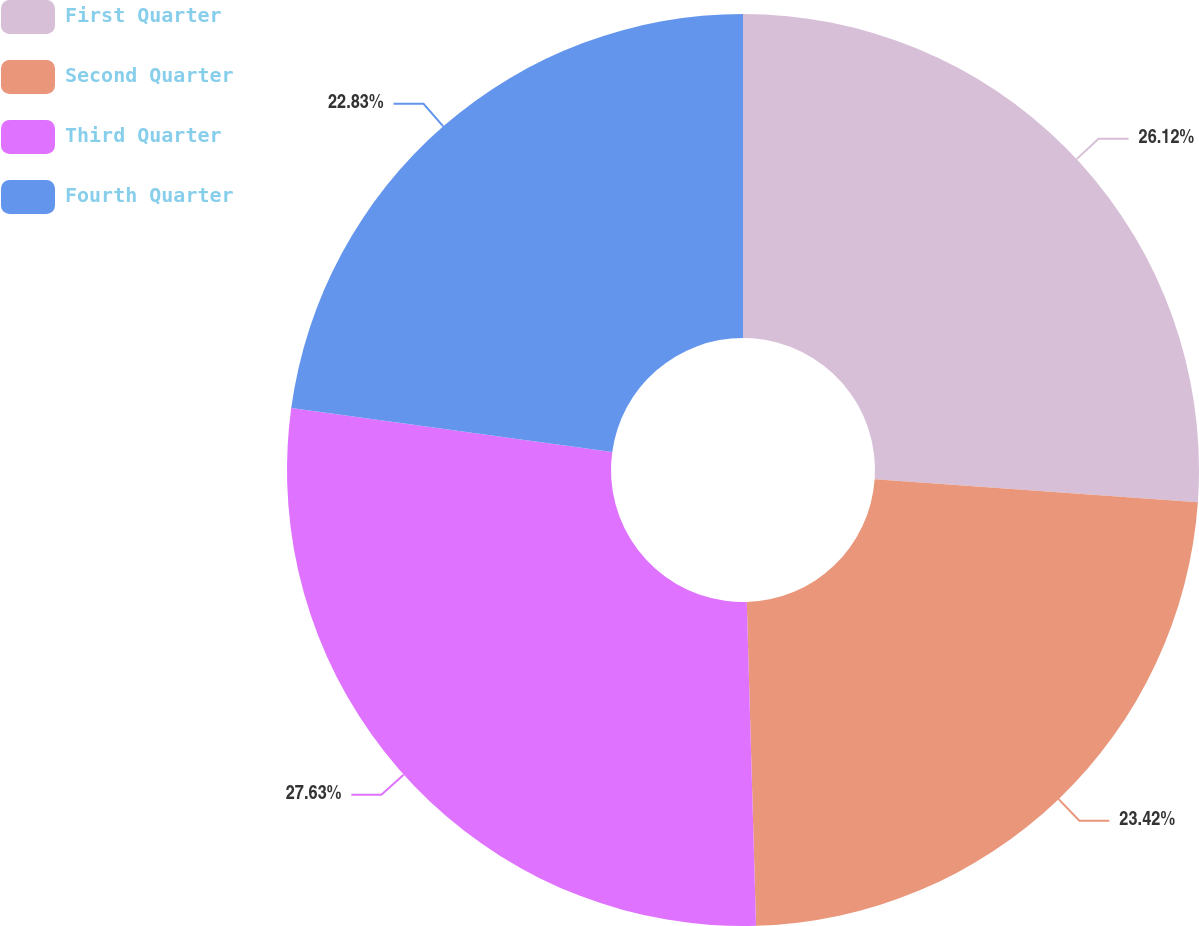Convert chart to OTSL. <chart><loc_0><loc_0><loc_500><loc_500><pie_chart><fcel>First Quarter<fcel>Second Quarter<fcel>Third Quarter<fcel>Fourth Quarter<nl><fcel>26.12%<fcel>23.42%<fcel>27.62%<fcel>22.83%<nl></chart> 